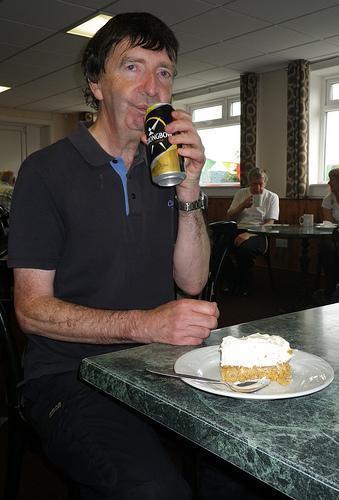How many people are in the image?
Give a very brief answer. 4. How many men in the photo are eating pie? there are people not eating pie too?
Give a very brief answer. 1. 